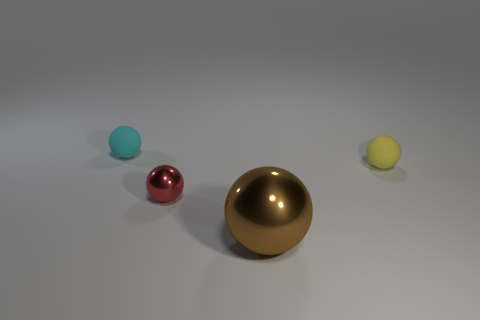Is the number of tiny metallic spheres behind the tiny yellow matte sphere less than the number of yellow rubber objects?
Make the answer very short. Yes. What number of matte things are the same color as the large metal sphere?
Offer a terse response. 0. What is the size of the rubber object to the left of the small yellow sphere?
Make the answer very short. Small. What shape is the tiny object that is both to the left of the small yellow object and in front of the small cyan matte thing?
Your answer should be very brief. Sphere. Are there any other cyan objects that have the same size as the cyan thing?
Provide a short and direct response. No. Does the tiny matte thing right of the small red metal ball have the same shape as the brown thing?
Offer a very short reply. Yes. Does the yellow thing have the same shape as the large thing?
Make the answer very short. Yes. Are there any small yellow objects that have the same shape as the red shiny thing?
Give a very brief answer. Yes. What shape is the small object that is behind the matte ball that is right of the large metallic ball?
Your response must be concise. Sphere. There is a small matte ball behind the small yellow matte thing; what is its color?
Offer a terse response. Cyan. 